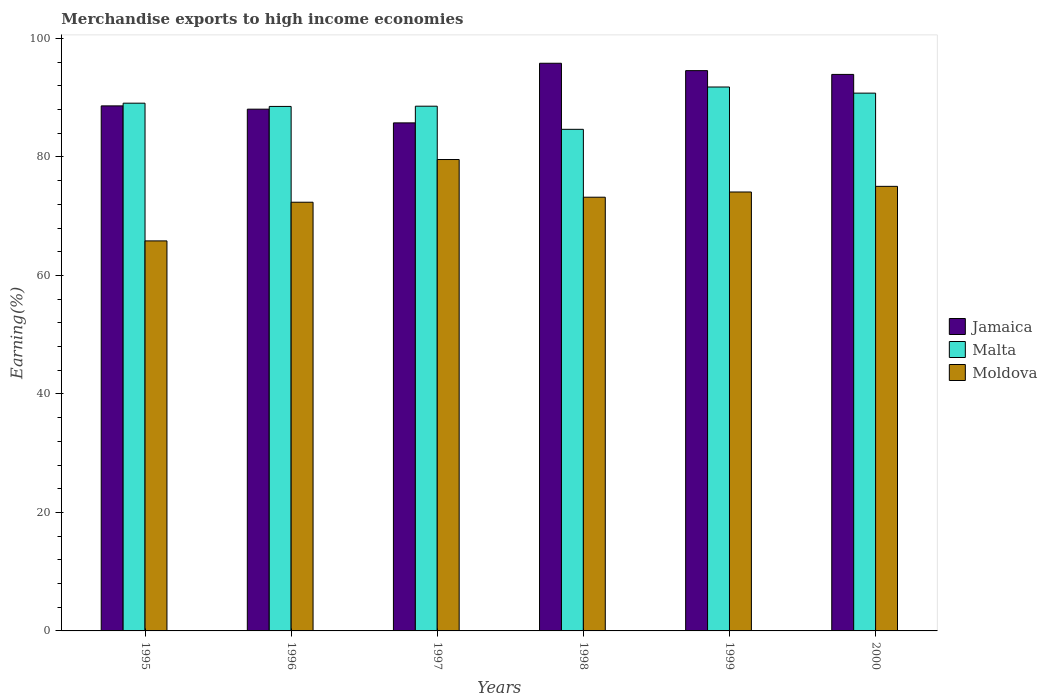How many groups of bars are there?
Make the answer very short. 6. Are the number of bars per tick equal to the number of legend labels?
Your answer should be compact. Yes. Are the number of bars on each tick of the X-axis equal?
Your response must be concise. Yes. What is the percentage of amount earned from merchandise exports in Malta in 1995?
Make the answer very short. 89.08. Across all years, what is the maximum percentage of amount earned from merchandise exports in Moldova?
Ensure brevity in your answer.  79.57. Across all years, what is the minimum percentage of amount earned from merchandise exports in Moldova?
Provide a succinct answer. 65.84. In which year was the percentage of amount earned from merchandise exports in Malta maximum?
Keep it short and to the point. 1999. What is the total percentage of amount earned from merchandise exports in Moldova in the graph?
Your response must be concise. 440.12. What is the difference between the percentage of amount earned from merchandise exports in Malta in 1999 and that in 2000?
Provide a succinct answer. 1.03. What is the difference between the percentage of amount earned from merchandise exports in Jamaica in 1999 and the percentage of amount earned from merchandise exports in Malta in 1995?
Your answer should be compact. 5.49. What is the average percentage of amount earned from merchandise exports in Malta per year?
Ensure brevity in your answer.  88.91. In the year 1996, what is the difference between the percentage of amount earned from merchandise exports in Malta and percentage of amount earned from merchandise exports in Jamaica?
Your answer should be very brief. 0.46. In how many years, is the percentage of amount earned from merchandise exports in Malta greater than 64 %?
Provide a succinct answer. 6. What is the ratio of the percentage of amount earned from merchandise exports in Moldova in 1996 to that in 1999?
Your answer should be very brief. 0.98. What is the difference between the highest and the second highest percentage of amount earned from merchandise exports in Malta?
Offer a very short reply. 1.03. What is the difference between the highest and the lowest percentage of amount earned from merchandise exports in Malta?
Your answer should be compact. 7.14. Is the sum of the percentage of amount earned from merchandise exports in Jamaica in 1995 and 1996 greater than the maximum percentage of amount earned from merchandise exports in Moldova across all years?
Offer a terse response. Yes. What does the 1st bar from the left in 1998 represents?
Offer a very short reply. Jamaica. What does the 2nd bar from the right in 1996 represents?
Your answer should be very brief. Malta. How many bars are there?
Ensure brevity in your answer.  18. Are all the bars in the graph horizontal?
Your answer should be very brief. No. What is the difference between two consecutive major ticks on the Y-axis?
Offer a terse response. 20. Are the values on the major ticks of Y-axis written in scientific E-notation?
Provide a succinct answer. No. Does the graph contain any zero values?
Give a very brief answer. No. Does the graph contain grids?
Your response must be concise. No. How many legend labels are there?
Give a very brief answer. 3. How are the legend labels stacked?
Ensure brevity in your answer.  Vertical. What is the title of the graph?
Ensure brevity in your answer.  Merchandise exports to high income economies. What is the label or title of the Y-axis?
Your answer should be compact. Earning(%). What is the Earning(%) in Jamaica in 1995?
Provide a succinct answer. 88.63. What is the Earning(%) of Malta in 1995?
Offer a terse response. 89.08. What is the Earning(%) of Moldova in 1995?
Ensure brevity in your answer.  65.84. What is the Earning(%) in Jamaica in 1996?
Keep it short and to the point. 88.07. What is the Earning(%) of Malta in 1996?
Your answer should be very brief. 88.53. What is the Earning(%) of Moldova in 1996?
Keep it short and to the point. 72.36. What is the Earning(%) in Jamaica in 1997?
Your response must be concise. 85.76. What is the Earning(%) of Malta in 1997?
Provide a succinct answer. 88.57. What is the Earning(%) of Moldova in 1997?
Keep it short and to the point. 79.57. What is the Earning(%) of Jamaica in 1998?
Your answer should be very brief. 95.82. What is the Earning(%) in Malta in 1998?
Your response must be concise. 84.67. What is the Earning(%) in Moldova in 1998?
Your answer should be compact. 73.21. What is the Earning(%) of Jamaica in 1999?
Your answer should be compact. 94.58. What is the Earning(%) in Malta in 1999?
Offer a very short reply. 91.81. What is the Earning(%) of Moldova in 1999?
Your response must be concise. 74.09. What is the Earning(%) of Jamaica in 2000?
Provide a succinct answer. 93.94. What is the Earning(%) in Malta in 2000?
Make the answer very short. 90.78. What is the Earning(%) of Moldova in 2000?
Your answer should be very brief. 75.04. Across all years, what is the maximum Earning(%) in Jamaica?
Keep it short and to the point. 95.82. Across all years, what is the maximum Earning(%) in Malta?
Your response must be concise. 91.81. Across all years, what is the maximum Earning(%) of Moldova?
Your response must be concise. 79.57. Across all years, what is the minimum Earning(%) of Jamaica?
Your response must be concise. 85.76. Across all years, what is the minimum Earning(%) in Malta?
Ensure brevity in your answer.  84.67. Across all years, what is the minimum Earning(%) of Moldova?
Give a very brief answer. 65.84. What is the total Earning(%) of Jamaica in the graph?
Offer a terse response. 546.79. What is the total Earning(%) of Malta in the graph?
Provide a succinct answer. 533.45. What is the total Earning(%) in Moldova in the graph?
Your answer should be very brief. 440.12. What is the difference between the Earning(%) of Jamaica in 1995 and that in 1996?
Ensure brevity in your answer.  0.56. What is the difference between the Earning(%) in Malta in 1995 and that in 1996?
Make the answer very short. 0.55. What is the difference between the Earning(%) in Moldova in 1995 and that in 1996?
Provide a succinct answer. -6.53. What is the difference between the Earning(%) of Jamaica in 1995 and that in 1997?
Offer a terse response. 2.87. What is the difference between the Earning(%) in Malta in 1995 and that in 1997?
Provide a short and direct response. 0.51. What is the difference between the Earning(%) in Moldova in 1995 and that in 1997?
Offer a very short reply. -13.74. What is the difference between the Earning(%) in Jamaica in 1995 and that in 1998?
Give a very brief answer. -7.19. What is the difference between the Earning(%) in Malta in 1995 and that in 1998?
Offer a terse response. 4.41. What is the difference between the Earning(%) in Moldova in 1995 and that in 1998?
Keep it short and to the point. -7.38. What is the difference between the Earning(%) in Jamaica in 1995 and that in 1999?
Your answer should be compact. -5.95. What is the difference between the Earning(%) of Malta in 1995 and that in 1999?
Make the answer very short. -2.73. What is the difference between the Earning(%) in Moldova in 1995 and that in 1999?
Make the answer very short. -8.26. What is the difference between the Earning(%) in Jamaica in 1995 and that in 2000?
Give a very brief answer. -5.31. What is the difference between the Earning(%) in Malta in 1995 and that in 2000?
Provide a short and direct response. -1.7. What is the difference between the Earning(%) of Moldova in 1995 and that in 2000?
Give a very brief answer. -9.21. What is the difference between the Earning(%) of Jamaica in 1996 and that in 1997?
Ensure brevity in your answer.  2.31. What is the difference between the Earning(%) in Malta in 1996 and that in 1997?
Offer a very short reply. -0.04. What is the difference between the Earning(%) in Moldova in 1996 and that in 1997?
Your response must be concise. -7.21. What is the difference between the Earning(%) in Jamaica in 1996 and that in 1998?
Give a very brief answer. -7.75. What is the difference between the Earning(%) in Malta in 1996 and that in 1998?
Ensure brevity in your answer.  3.86. What is the difference between the Earning(%) of Moldova in 1996 and that in 1998?
Your response must be concise. -0.85. What is the difference between the Earning(%) in Jamaica in 1996 and that in 1999?
Make the answer very short. -6.5. What is the difference between the Earning(%) of Malta in 1996 and that in 1999?
Provide a succinct answer. -3.28. What is the difference between the Earning(%) in Moldova in 1996 and that in 1999?
Offer a very short reply. -1.73. What is the difference between the Earning(%) of Jamaica in 1996 and that in 2000?
Give a very brief answer. -5.87. What is the difference between the Earning(%) in Malta in 1996 and that in 2000?
Make the answer very short. -2.24. What is the difference between the Earning(%) in Moldova in 1996 and that in 2000?
Your answer should be compact. -2.68. What is the difference between the Earning(%) of Jamaica in 1997 and that in 1998?
Keep it short and to the point. -10.06. What is the difference between the Earning(%) of Malta in 1997 and that in 1998?
Provide a succinct answer. 3.9. What is the difference between the Earning(%) of Moldova in 1997 and that in 1998?
Your answer should be compact. 6.36. What is the difference between the Earning(%) in Jamaica in 1997 and that in 1999?
Make the answer very short. -8.82. What is the difference between the Earning(%) of Malta in 1997 and that in 1999?
Give a very brief answer. -3.24. What is the difference between the Earning(%) in Moldova in 1997 and that in 1999?
Offer a very short reply. 5.48. What is the difference between the Earning(%) in Jamaica in 1997 and that in 2000?
Make the answer very short. -8.18. What is the difference between the Earning(%) in Malta in 1997 and that in 2000?
Offer a very short reply. -2.21. What is the difference between the Earning(%) of Moldova in 1997 and that in 2000?
Offer a very short reply. 4.53. What is the difference between the Earning(%) of Jamaica in 1998 and that in 1999?
Offer a terse response. 1.25. What is the difference between the Earning(%) in Malta in 1998 and that in 1999?
Your response must be concise. -7.14. What is the difference between the Earning(%) of Moldova in 1998 and that in 1999?
Provide a short and direct response. -0.88. What is the difference between the Earning(%) in Jamaica in 1998 and that in 2000?
Offer a very short reply. 1.88. What is the difference between the Earning(%) of Malta in 1998 and that in 2000?
Provide a succinct answer. -6.11. What is the difference between the Earning(%) in Moldova in 1998 and that in 2000?
Provide a short and direct response. -1.83. What is the difference between the Earning(%) in Jamaica in 1999 and that in 2000?
Your response must be concise. 0.64. What is the difference between the Earning(%) of Malta in 1999 and that in 2000?
Make the answer very short. 1.03. What is the difference between the Earning(%) in Moldova in 1999 and that in 2000?
Your answer should be very brief. -0.95. What is the difference between the Earning(%) of Jamaica in 1995 and the Earning(%) of Malta in 1996?
Provide a short and direct response. 0.09. What is the difference between the Earning(%) in Jamaica in 1995 and the Earning(%) in Moldova in 1996?
Your answer should be compact. 16.26. What is the difference between the Earning(%) of Malta in 1995 and the Earning(%) of Moldova in 1996?
Give a very brief answer. 16.72. What is the difference between the Earning(%) of Jamaica in 1995 and the Earning(%) of Malta in 1997?
Your answer should be very brief. 0.05. What is the difference between the Earning(%) in Jamaica in 1995 and the Earning(%) in Moldova in 1997?
Your answer should be very brief. 9.05. What is the difference between the Earning(%) in Malta in 1995 and the Earning(%) in Moldova in 1997?
Give a very brief answer. 9.51. What is the difference between the Earning(%) in Jamaica in 1995 and the Earning(%) in Malta in 1998?
Ensure brevity in your answer.  3.96. What is the difference between the Earning(%) in Jamaica in 1995 and the Earning(%) in Moldova in 1998?
Ensure brevity in your answer.  15.42. What is the difference between the Earning(%) of Malta in 1995 and the Earning(%) of Moldova in 1998?
Your response must be concise. 15.87. What is the difference between the Earning(%) of Jamaica in 1995 and the Earning(%) of Malta in 1999?
Make the answer very short. -3.19. What is the difference between the Earning(%) of Jamaica in 1995 and the Earning(%) of Moldova in 1999?
Keep it short and to the point. 14.53. What is the difference between the Earning(%) of Malta in 1995 and the Earning(%) of Moldova in 1999?
Provide a succinct answer. 14.99. What is the difference between the Earning(%) in Jamaica in 1995 and the Earning(%) in Malta in 2000?
Your response must be concise. -2.15. What is the difference between the Earning(%) of Jamaica in 1995 and the Earning(%) of Moldova in 2000?
Your answer should be compact. 13.58. What is the difference between the Earning(%) of Malta in 1995 and the Earning(%) of Moldova in 2000?
Make the answer very short. 14.04. What is the difference between the Earning(%) in Jamaica in 1996 and the Earning(%) in Malta in 1997?
Make the answer very short. -0.5. What is the difference between the Earning(%) of Jamaica in 1996 and the Earning(%) of Moldova in 1997?
Offer a terse response. 8.5. What is the difference between the Earning(%) of Malta in 1996 and the Earning(%) of Moldova in 1997?
Offer a very short reply. 8.96. What is the difference between the Earning(%) of Jamaica in 1996 and the Earning(%) of Malta in 1998?
Your answer should be very brief. 3.4. What is the difference between the Earning(%) in Jamaica in 1996 and the Earning(%) in Moldova in 1998?
Keep it short and to the point. 14.86. What is the difference between the Earning(%) in Malta in 1996 and the Earning(%) in Moldova in 1998?
Offer a terse response. 15.32. What is the difference between the Earning(%) in Jamaica in 1996 and the Earning(%) in Malta in 1999?
Make the answer very short. -3.74. What is the difference between the Earning(%) of Jamaica in 1996 and the Earning(%) of Moldova in 1999?
Keep it short and to the point. 13.98. What is the difference between the Earning(%) of Malta in 1996 and the Earning(%) of Moldova in 1999?
Ensure brevity in your answer.  14.44. What is the difference between the Earning(%) in Jamaica in 1996 and the Earning(%) in Malta in 2000?
Provide a short and direct response. -2.71. What is the difference between the Earning(%) of Jamaica in 1996 and the Earning(%) of Moldova in 2000?
Your response must be concise. 13.03. What is the difference between the Earning(%) of Malta in 1996 and the Earning(%) of Moldova in 2000?
Your response must be concise. 13.49. What is the difference between the Earning(%) in Jamaica in 1997 and the Earning(%) in Malta in 1998?
Offer a terse response. 1.09. What is the difference between the Earning(%) of Jamaica in 1997 and the Earning(%) of Moldova in 1998?
Offer a terse response. 12.55. What is the difference between the Earning(%) of Malta in 1997 and the Earning(%) of Moldova in 1998?
Make the answer very short. 15.36. What is the difference between the Earning(%) of Jamaica in 1997 and the Earning(%) of Malta in 1999?
Give a very brief answer. -6.05. What is the difference between the Earning(%) of Jamaica in 1997 and the Earning(%) of Moldova in 1999?
Ensure brevity in your answer.  11.67. What is the difference between the Earning(%) in Malta in 1997 and the Earning(%) in Moldova in 1999?
Offer a very short reply. 14.48. What is the difference between the Earning(%) of Jamaica in 1997 and the Earning(%) of Malta in 2000?
Keep it short and to the point. -5.02. What is the difference between the Earning(%) of Jamaica in 1997 and the Earning(%) of Moldova in 2000?
Offer a very short reply. 10.72. What is the difference between the Earning(%) in Malta in 1997 and the Earning(%) in Moldova in 2000?
Keep it short and to the point. 13.53. What is the difference between the Earning(%) in Jamaica in 1998 and the Earning(%) in Malta in 1999?
Your response must be concise. 4.01. What is the difference between the Earning(%) of Jamaica in 1998 and the Earning(%) of Moldova in 1999?
Ensure brevity in your answer.  21.73. What is the difference between the Earning(%) in Malta in 1998 and the Earning(%) in Moldova in 1999?
Your answer should be very brief. 10.58. What is the difference between the Earning(%) in Jamaica in 1998 and the Earning(%) in Malta in 2000?
Provide a short and direct response. 5.04. What is the difference between the Earning(%) in Jamaica in 1998 and the Earning(%) in Moldova in 2000?
Your answer should be very brief. 20.78. What is the difference between the Earning(%) in Malta in 1998 and the Earning(%) in Moldova in 2000?
Your answer should be compact. 9.63. What is the difference between the Earning(%) of Jamaica in 1999 and the Earning(%) of Malta in 2000?
Your response must be concise. 3.8. What is the difference between the Earning(%) of Jamaica in 1999 and the Earning(%) of Moldova in 2000?
Your answer should be very brief. 19.53. What is the difference between the Earning(%) of Malta in 1999 and the Earning(%) of Moldova in 2000?
Give a very brief answer. 16.77. What is the average Earning(%) in Jamaica per year?
Your answer should be very brief. 91.13. What is the average Earning(%) of Malta per year?
Ensure brevity in your answer.  88.91. What is the average Earning(%) in Moldova per year?
Offer a terse response. 73.35. In the year 1995, what is the difference between the Earning(%) in Jamaica and Earning(%) in Malta?
Keep it short and to the point. -0.46. In the year 1995, what is the difference between the Earning(%) of Jamaica and Earning(%) of Moldova?
Make the answer very short. 22.79. In the year 1995, what is the difference between the Earning(%) in Malta and Earning(%) in Moldova?
Keep it short and to the point. 23.25. In the year 1996, what is the difference between the Earning(%) in Jamaica and Earning(%) in Malta?
Your answer should be very brief. -0.46. In the year 1996, what is the difference between the Earning(%) of Jamaica and Earning(%) of Moldova?
Offer a very short reply. 15.71. In the year 1996, what is the difference between the Earning(%) in Malta and Earning(%) in Moldova?
Keep it short and to the point. 16.17. In the year 1997, what is the difference between the Earning(%) in Jamaica and Earning(%) in Malta?
Provide a short and direct response. -2.81. In the year 1997, what is the difference between the Earning(%) of Jamaica and Earning(%) of Moldova?
Make the answer very short. 6.19. In the year 1997, what is the difference between the Earning(%) of Malta and Earning(%) of Moldova?
Provide a succinct answer. 9. In the year 1998, what is the difference between the Earning(%) of Jamaica and Earning(%) of Malta?
Offer a very short reply. 11.15. In the year 1998, what is the difference between the Earning(%) in Jamaica and Earning(%) in Moldova?
Keep it short and to the point. 22.61. In the year 1998, what is the difference between the Earning(%) of Malta and Earning(%) of Moldova?
Your response must be concise. 11.46. In the year 1999, what is the difference between the Earning(%) in Jamaica and Earning(%) in Malta?
Provide a succinct answer. 2.76. In the year 1999, what is the difference between the Earning(%) in Jamaica and Earning(%) in Moldova?
Offer a very short reply. 20.48. In the year 1999, what is the difference between the Earning(%) in Malta and Earning(%) in Moldova?
Keep it short and to the point. 17.72. In the year 2000, what is the difference between the Earning(%) in Jamaica and Earning(%) in Malta?
Provide a succinct answer. 3.16. In the year 2000, what is the difference between the Earning(%) in Jamaica and Earning(%) in Moldova?
Keep it short and to the point. 18.9. In the year 2000, what is the difference between the Earning(%) of Malta and Earning(%) of Moldova?
Give a very brief answer. 15.74. What is the ratio of the Earning(%) in Moldova in 1995 to that in 1996?
Provide a succinct answer. 0.91. What is the ratio of the Earning(%) of Jamaica in 1995 to that in 1997?
Provide a succinct answer. 1.03. What is the ratio of the Earning(%) of Moldova in 1995 to that in 1997?
Provide a succinct answer. 0.83. What is the ratio of the Earning(%) in Jamaica in 1995 to that in 1998?
Keep it short and to the point. 0.92. What is the ratio of the Earning(%) of Malta in 1995 to that in 1998?
Offer a very short reply. 1.05. What is the ratio of the Earning(%) of Moldova in 1995 to that in 1998?
Provide a short and direct response. 0.9. What is the ratio of the Earning(%) of Jamaica in 1995 to that in 1999?
Make the answer very short. 0.94. What is the ratio of the Earning(%) of Malta in 1995 to that in 1999?
Offer a very short reply. 0.97. What is the ratio of the Earning(%) of Moldova in 1995 to that in 1999?
Your response must be concise. 0.89. What is the ratio of the Earning(%) of Jamaica in 1995 to that in 2000?
Provide a short and direct response. 0.94. What is the ratio of the Earning(%) in Malta in 1995 to that in 2000?
Your answer should be compact. 0.98. What is the ratio of the Earning(%) of Moldova in 1995 to that in 2000?
Offer a very short reply. 0.88. What is the ratio of the Earning(%) in Jamaica in 1996 to that in 1997?
Offer a very short reply. 1.03. What is the ratio of the Earning(%) of Malta in 1996 to that in 1997?
Your answer should be compact. 1. What is the ratio of the Earning(%) in Moldova in 1996 to that in 1997?
Give a very brief answer. 0.91. What is the ratio of the Earning(%) of Jamaica in 1996 to that in 1998?
Give a very brief answer. 0.92. What is the ratio of the Earning(%) of Malta in 1996 to that in 1998?
Provide a short and direct response. 1.05. What is the ratio of the Earning(%) of Moldova in 1996 to that in 1998?
Give a very brief answer. 0.99. What is the ratio of the Earning(%) of Jamaica in 1996 to that in 1999?
Ensure brevity in your answer.  0.93. What is the ratio of the Earning(%) in Malta in 1996 to that in 1999?
Your answer should be very brief. 0.96. What is the ratio of the Earning(%) of Moldova in 1996 to that in 1999?
Your answer should be very brief. 0.98. What is the ratio of the Earning(%) of Malta in 1996 to that in 2000?
Your answer should be compact. 0.98. What is the ratio of the Earning(%) in Moldova in 1996 to that in 2000?
Provide a short and direct response. 0.96. What is the ratio of the Earning(%) in Jamaica in 1997 to that in 1998?
Offer a very short reply. 0.9. What is the ratio of the Earning(%) of Malta in 1997 to that in 1998?
Your response must be concise. 1.05. What is the ratio of the Earning(%) in Moldova in 1997 to that in 1998?
Your answer should be compact. 1.09. What is the ratio of the Earning(%) in Jamaica in 1997 to that in 1999?
Ensure brevity in your answer.  0.91. What is the ratio of the Earning(%) of Malta in 1997 to that in 1999?
Keep it short and to the point. 0.96. What is the ratio of the Earning(%) of Moldova in 1997 to that in 1999?
Offer a very short reply. 1.07. What is the ratio of the Earning(%) of Jamaica in 1997 to that in 2000?
Keep it short and to the point. 0.91. What is the ratio of the Earning(%) in Malta in 1997 to that in 2000?
Ensure brevity in your answer.  0.98. What is the ratio of the Earning(%) in Moldova in 1997 to that in 2000?
Ensure brevity in your answer.  1.06. What is the ratio of the Earning(%) in Jamaica in 1998 to that in 1999?
Ensure brevity in your answer.  1.01. What is the ratio of the Earning(%) in Malta in 1998 to that in 1999?
Your answer should be very brief. 0.92. What is the ratio of the Earning(%) of Moldova in 1998 to that in 1999?
Offer a terse response. 0.99. What is the ratio of the Earning(%) of Jamaica in 1998 to that in 2000?
Ensure brevity in your answer.  1.02. What is the ratio of the Earning(%) of Malta in 1998 to that in 2000?
Your answer should be compact. 0.93. What is the ratio of the Earning(%) in Moldova in 1998 to that in 2000?
Make the answer very short. 0.98. What is the ratio of the Earning(%) in Jamaica in 1999 to that in 2000?
Your answer should be compact. 1.01. What is the ratio of the Earning(%) in Malta in 1999 to that in 2000?
Provide a succinct answer. 1.01. What is the ratio of the Earning(%) of Moldova in 1999 to that in 2000?
Make the answer very short. 0.99. What is the difference between the highest and the second highest Earning(%) of Jamaica?
Ensure brevity in your answer.  1.25. What is the difference between the highest and the second highest Earning(%) in Malta?
Give a very brief answer. 1.03. What is the difference between the highest and the second highest Earning(%) in Moldova?
Your answer should be very brief. 4.53. What is the difference between the highest and the lowest Earning(%) of Jamaica?
Provide a succinct answer. 10.06. What is the difference between the highest and the lowest Earning(%) in Malta?
Offer a terse response. 7.14. What is the difference between the highest and the lowest Earning(%) in Moldova?
Offer a very short reply. 13.74. 